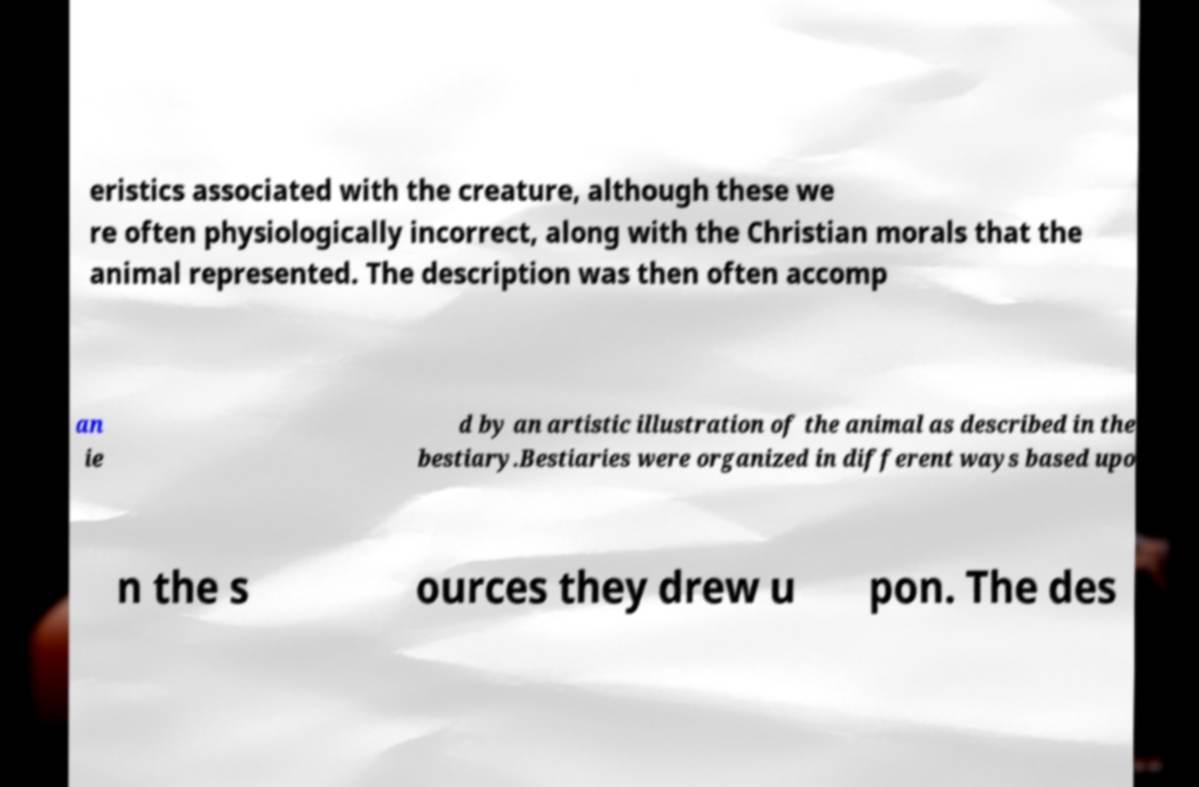Could you assist in decoding the text presented in this image and type it out clearly? eristics associated with the creature, although these we re often physiologically incorrect, along with the Christian morals that the animal represented. The description was then often accomp an ie d by an artistic illustration of the animal as described in the bestiary.Bestiaries were organized in different ways based upo n the s ources they drew u pon. The des 